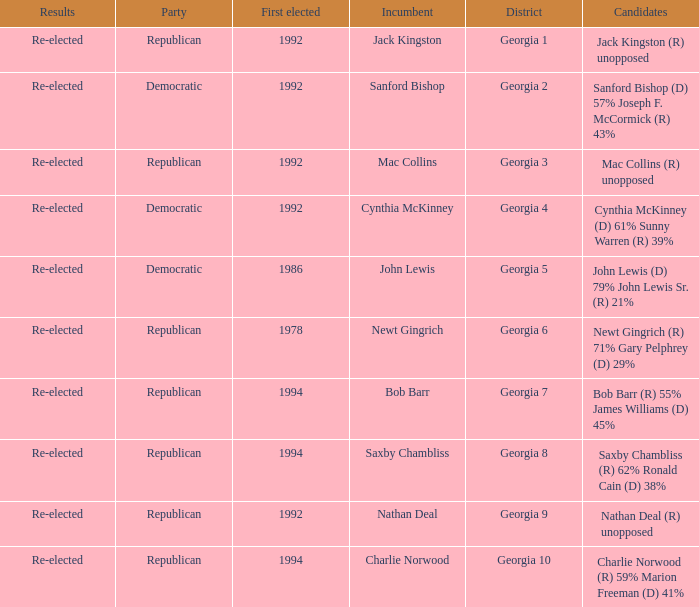Who were the candidates in the election where Saxby Chambliss was the incumbent? Saxby Chambliss (R) 62% Ronald Cain (D) 38%. 